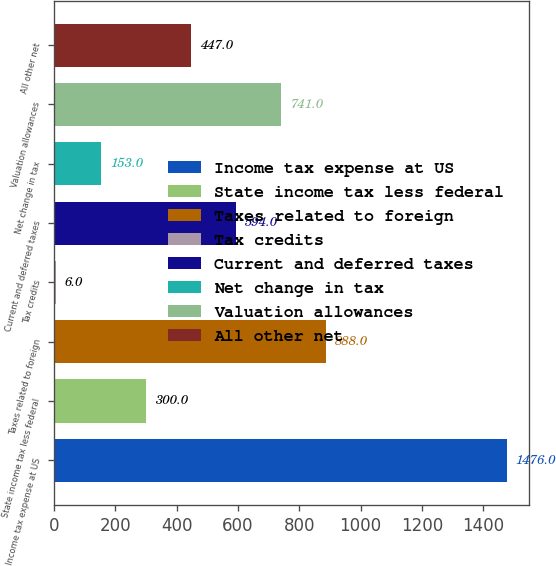Convert chart to OTSL. <chart><loc_0><loc_0><loc_500><loc_500><bar_chart><fcel>Income tax expense at US<fcel>State income tax less federal<fcel>Taxes related to foreign<fcel>Tax credits<fcel>Current and deferred taxes<fcel>Net change in tax<fcel>Valuation allowances<fcel>All other net<nl><fcel>1476<fcel>300<fcel>888<fcel>6<fcel>594<fcel>153<fcel>741<fcel>447<nl></chart> 